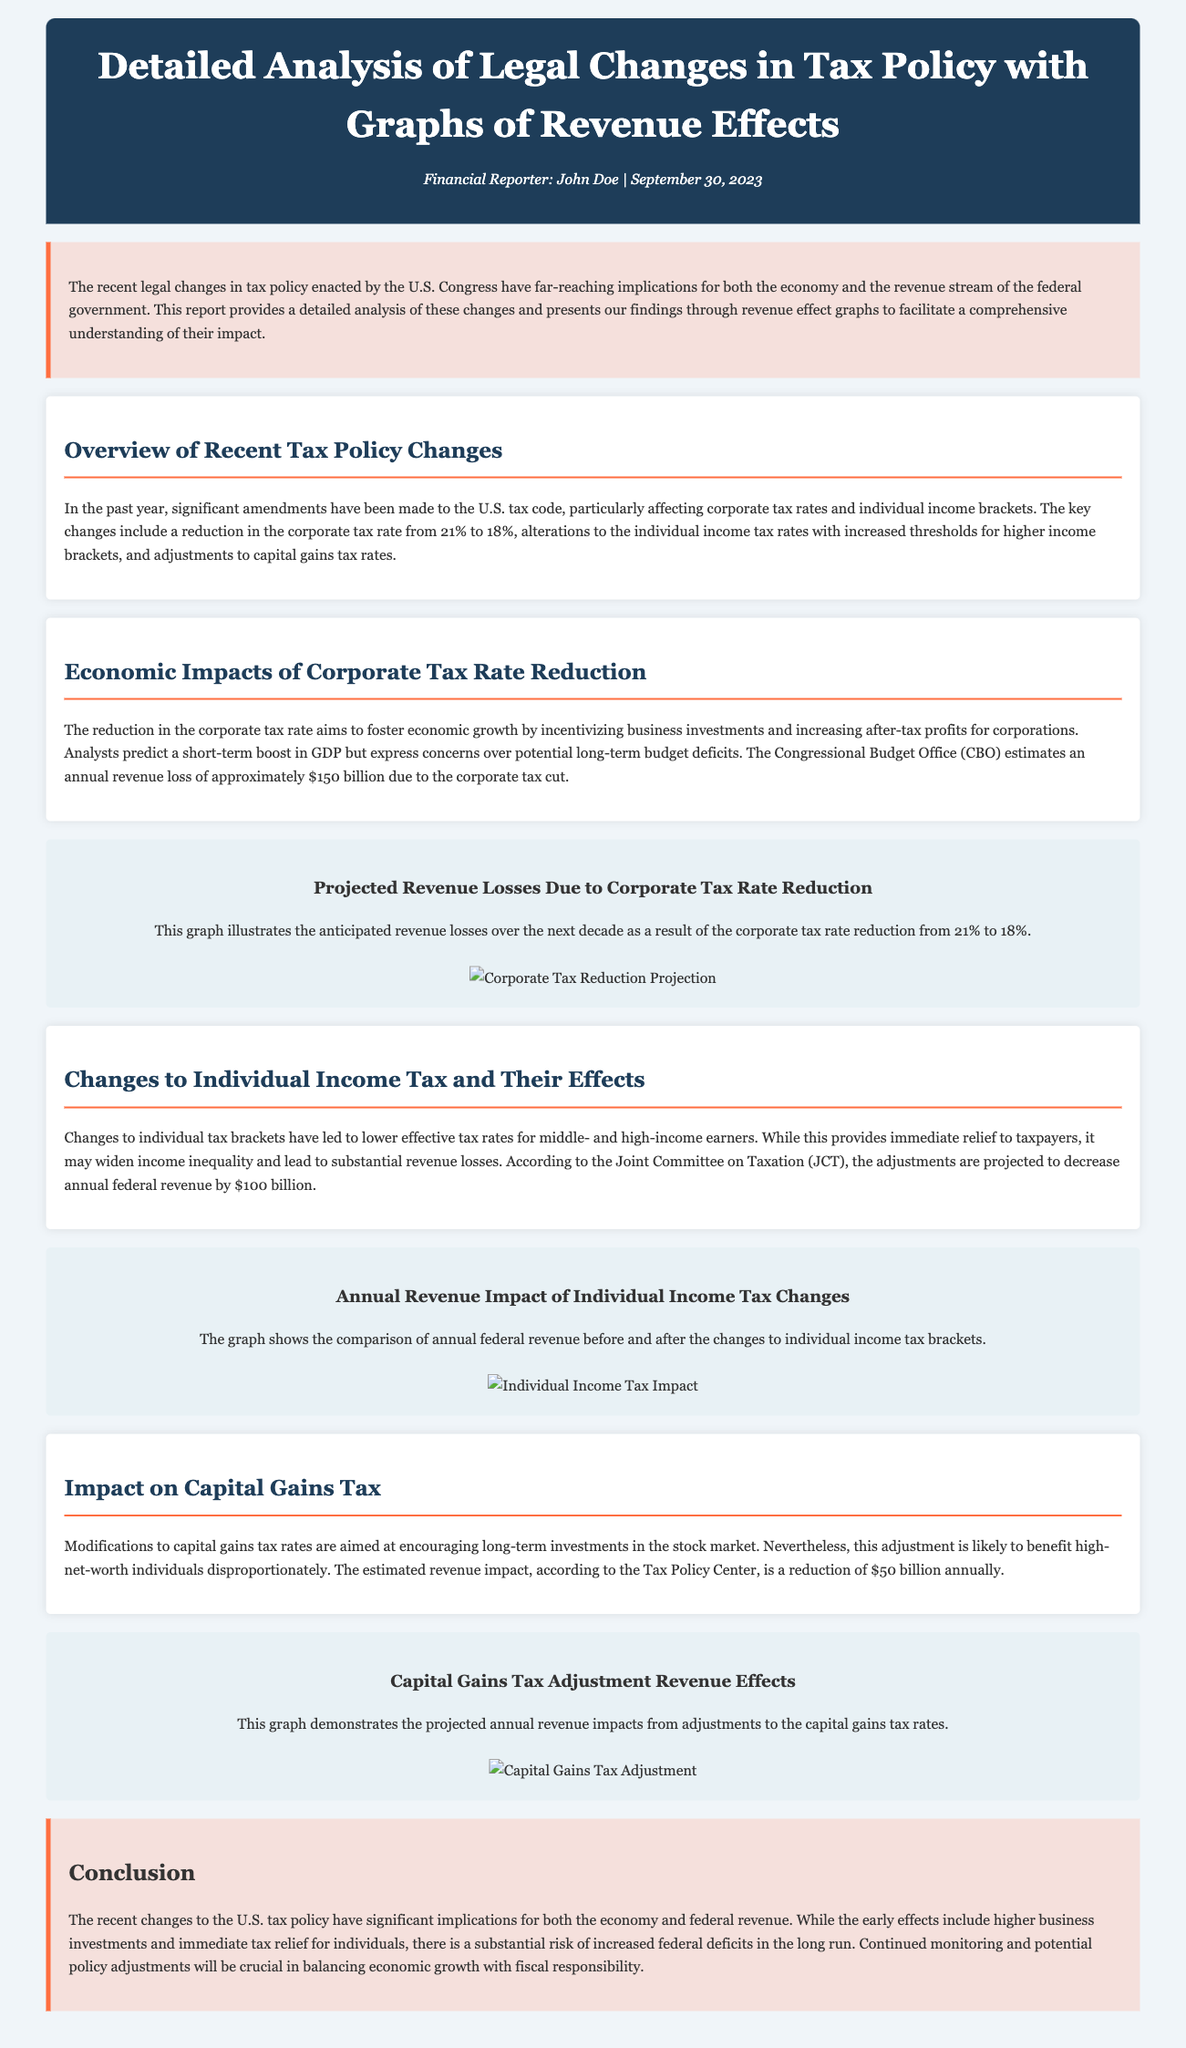What major tax rate was reduced? The document states that the corporate tax rate was reduced from 21% to 18%.
Answer: 18% What is the projected annual revenue loss due to the corporate tax cut? The Congressional Budget Office estimates an annual revenue loss of approximately $150 billion due to the corporate tax cut.
Answer: $150 billion How much annual federal revenue is projected to decrease due to changes to individual income tax? According to the Joint Committee on Taxation, the adjustments are projected to decrease annual federal revenue by $100 billion.
Answer: $100 billion What is the estimated annual revenue impact from adjustments to capital gains tax rates? The estimated revenue impact, according to the Tax Policy Center, is a reduction of $50 billion annually.
Answer: $50 billion What does the document suggest about the long-term effects of the corporate tax rate reduction? Analysts express concerns over potential long-term budget deficits due to the corporate tax cut.
Answer: Budget deficits What type of visual information is provided in the document to support the analysis? The document includes graphs to illustrate the anticipated revenue losses and impacts of tax policy changes.
Answer: Graphs What is the conclusion regarding federal deficits? The document indicates that there is a substantial risk of increased federal deficits in the long run.
Answer: Increased federal deficits 